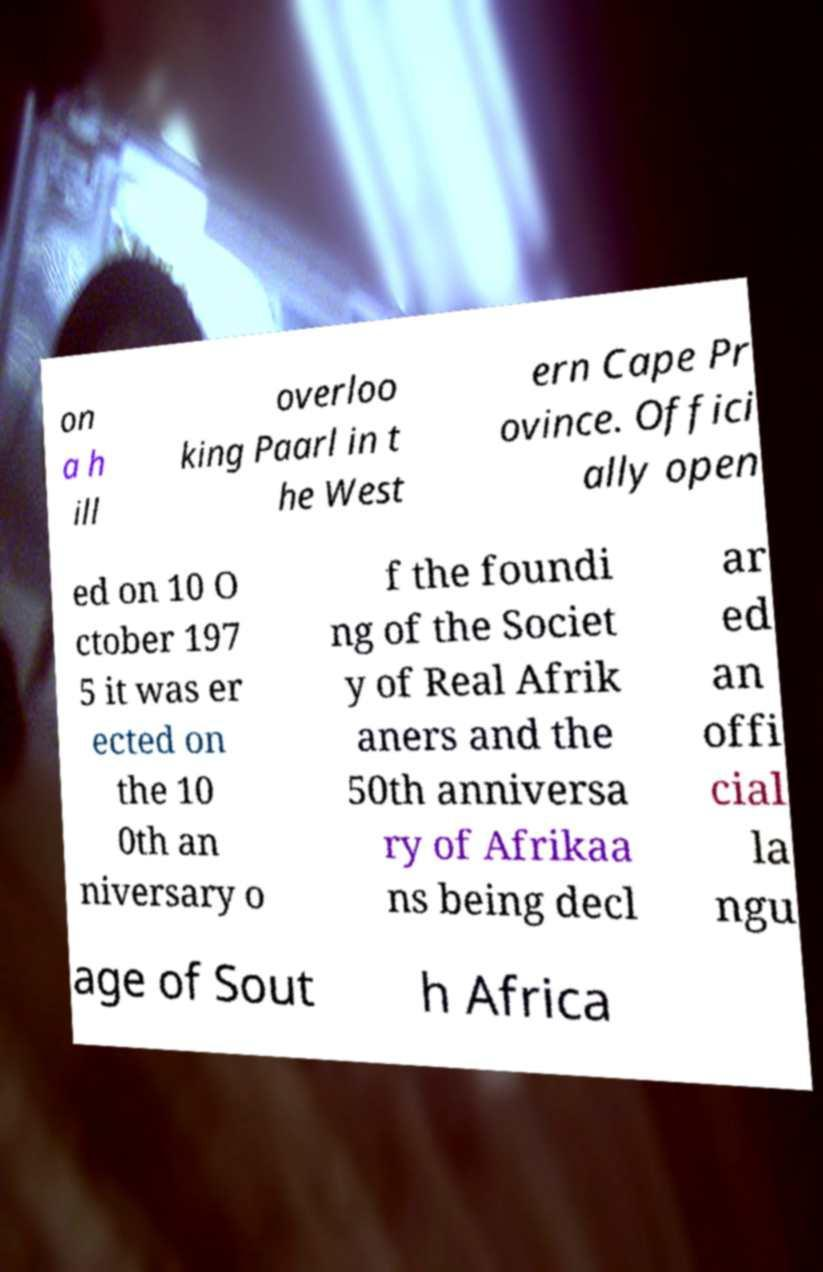For documentation purposes, I need the text within this image transcribed. Could you provide that? on a h ill overloo king Paarl in t he West ern Cape Pr ovince. Offici ally open ed on 10 O ctober 197 5 it was er ected on the 10 0th an niversary o f the foundi ng of the Societ y of Real Afrik aners and the 50th anniversa ry of Afrikaa ns being decl ar ed an offi cial la ngu age of Sout h Africa 